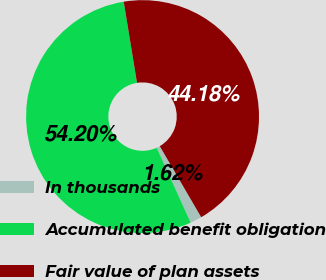<chart> <loc_0><loc_0><loc_500><loc_500><pie_chart><fcel>In thousands<fcel>Accumulated benefit obligation<fcel>Fair value of plan assets<nl><fcel>1.62%<fcel>54.2%<fcel>44.18%<nl></chart> 